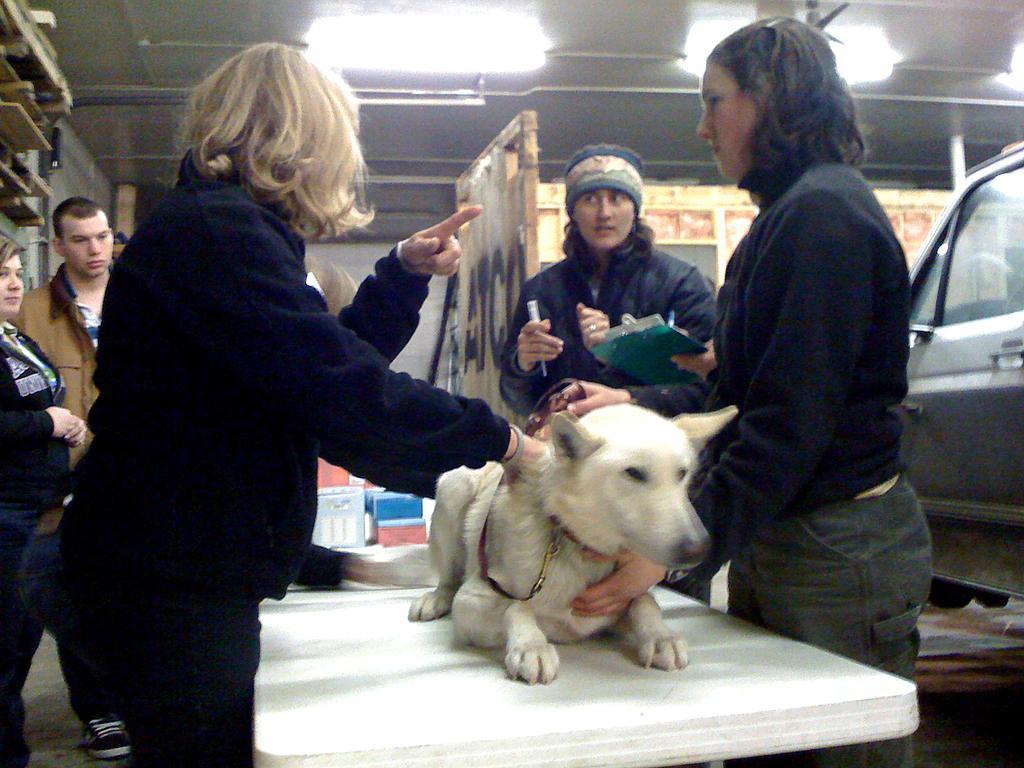How would you summarize this image in a sentence or two? a person is standing. behind her 2 more people are standing. at the right side 2 people are standing and a white color dog is present on the desk. behind them at the right side there is a car. 